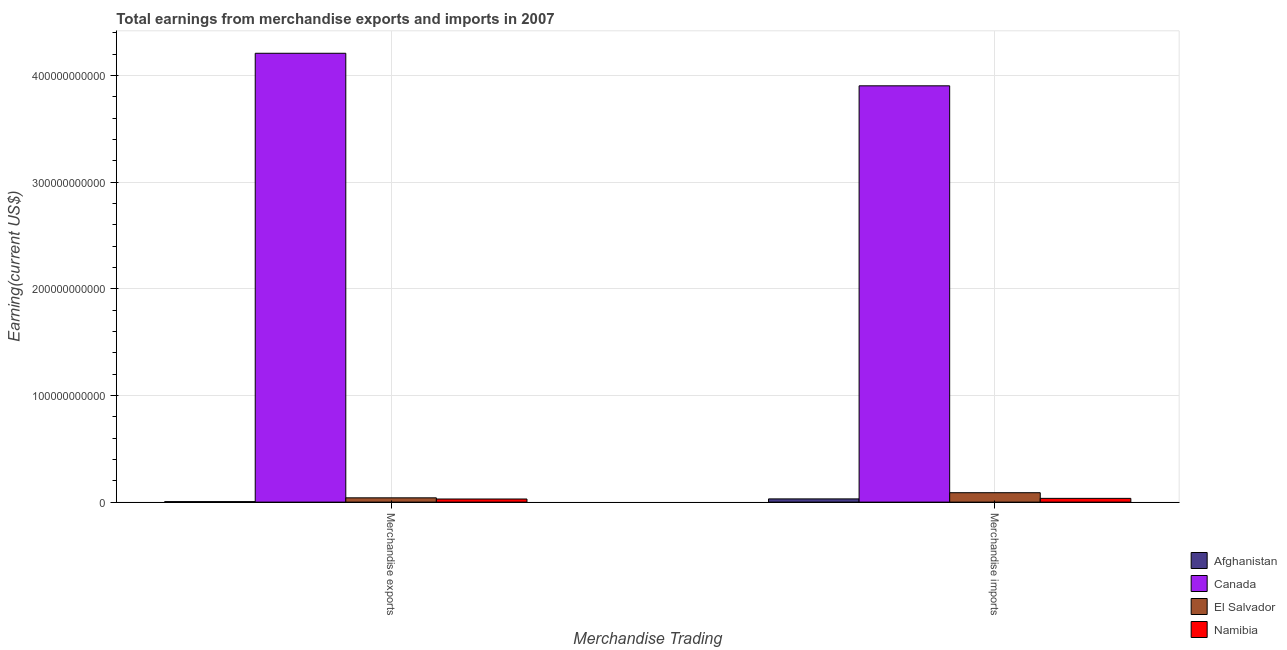How many different coloured bars are there?
Your answer should be very brief. 4. How many groups of bars are there?
Provide a short and direct response. 2. Are the number of bars per tick equal to the number of legend labels?
Your answer should be very brief. Yes. Are the number of bars on each tick of the X-axis equal?
Ensure brevity in your answer.  Yes. How many bars are there on the 2nd tick from the right?
Give a very brief answer. 4. What is the earnings from merchandise exports in Canada?
Your response must be concise. 4.21e+11. Across all countries, what is the maximum earnings from merchandise imports?
Make the answer very short. 3.90e+11. Across all countries, what is the minimum earnings from merchandise exports?
Make the answer very short. 4.54e+08. In which country was the earnings from merchandise imports maximum?
Make the answer very short. Canada. In which country was the earnings from merchandise exports minimum?
Give a very brief answer. Afghanistan. What is the total earnings from merchandise exports in the graph?
Offer a very short reply. 4.28e+11. What is the difference between the earnings from merchandise exports in Afghanistan and that in Namibia?
Offer a terse response. -2.47e+09. What is the difference between the earnings from merchandise imports in Afghanistan and the earnings from merchandise exports in Canada?
Your answer should be very brief. -4.18e+11. What is the average earnings from merchandise imports per country?
Your answer should be very brief. 1.01e+11. What is the difference between the earnings from merchandise exports and earnings from merchandise imports in Canada?
Offer a very short reply. 3.05e+1. What is the ratio of the earnings from merchandise imports in Afghanistan to that in Namibia?
Offer a very short reply. 0.86. What does the 1st bar from the left in Merchandise imports represents?
Provide a succinct answer. Afghanistan. What does the 1st bar from the right in Merchandise exports represents?
Give a very brief answer. Namibia. What is the difference between two consecutive major ticks on the Y-axis?
Give a very brief answer. 1.00e+11. Where does the legend appear in the graph?
Make the answer very short. Bottom right. How are the legend labels stacked?
Give a very brief answer. Vertical. What is the title of the graph?
Your answer should be very brief. Total earnings from merchandise exports and imports in 2007. What is the label or title of the X-axis?
Your answer should be compact. Merchandise Trading. What is the label or title of the Y-axis?
Provide a succinct answer. Earning(current US$). What is the Earning(current US$) of Afghanistan in Merchandise exports?
Ensure brevity in your answer.  4.54e+08. What is the Earning(current US$) of Canada in Merchandise exports?
Offer a terse response. 4.21e+11. What is the Earning(current US$) of El Salvador in Merchandise exports?
Give a very brief answer. 4.01e+09. What is the Earning(current US$) of Namibia in Merchandise exports?
Your answer should be compact. 2.92e+09. What is the Earning(current US$) of Afghanistan in Merchandise imports?
Your answer should be very brief. 3.02e+09. What is the Earning(current US$) in Canada in Merchandise imports?
Make the answer very short. 3.90e+11. What is the Earning(current US$) in El Salvador in Merchandise imports?
Give a very brief answer. 8.82e+09. What is the Earning(current US$) in Namibia in Merchandise imports?
Provide a succinct answer. 3.52e+09. Across all Merchandise Trading, what is the maximum Earning(current US$) in Afghanistan?
Offer a very short reply. 3.02e+09. Across all Merchandise Trading, what is the maximum Earning(current US$) in Canada?
Give a very brief answer. 4.21e+11. Across all Merchandise Trading, what is the maximum Earning(current US$) of El Salvador?
Your response must be concise. 8.82e+09. Across all Merchandise Trading, what is the maximum Earning(current US$) in Namibia?
Make the answer very short. 3.52e+09. Across all Merchandise Trading, what is the minimum Earning(current US$) of Afghanistan?
Make the answer very short. 4.54e+08. Across all Merchandise Trading, what is the minimum Earning(current US$) of Canada?
Your answer should be very brief. 3.90e+11. Across all Merchandise Trading, what is the minimum Earning(current US$) of El Salvador?
Ensure brevity in your answer.  4.01e+09. Across all Merchandise Trading, what is the minimum Earning(current US$) of Namibia?
Provide a short and direct response. 2.92e+09. What is the total Earning(current US$) of Afghanistan in the graph?
Make the answer very short. 3.48e+09. What is the total Earning(current US$) in Canada in the graph?
Make the answer very short. 8.11e+11. What is the total Earning(current US$) of El Salvador in the graph?
Your answer should be very brief. 1.28e+1. What is the total Earning(current US$) of Namibia in the graph?
Make the answer very short. 6.44e+09. What is the difference between the Earning(current US$) in Afghanistan in Merchandise exports and that in Merchandise imports?
Provide a succinct answer. -2.57e+09. What is the difference between the Earning(current US$) of Canada in Merchandise exports and that in Merchandise imports?
Provide a succinct answer. 3.05e+1. What is the difference between the Earning(current US$) in El Salvador in Merchandise exports and that in Merchandise imports?
Offer a very short reply. -4.81e+09. What is the difference between the Earning(current US$) of Namibia in Merchandise exports and that in Merchandise imports?
Your answer should be very brief. -5.98e+08. What is the difference between the Earning(current US$) in Afghanistan in Merchandise exports and the Earning(current US$) in Canada in Merchandise imports?
Offer a terse response. -3.90e+11. What is the difference between the Earning(current US$) of Afghanistan in Merchandise exports and the Earning(current US$) of El Salvador in Merchandise imports?
Offer a very short reply. -8.37e+09. What is the difference between the Earning(current US$) in Afghanistan in Merchandise exports and the Earning(current US$) in Namibia in Merchandise imports?
Provide a short and direct response. -3.07e+09. What is the difference between the Earning(current US$) in Canada in Merchandise exports and the Earning(current US$) in El Salvador in Merchandise imports?
Provide a succinct answer. 4.12e+11. What is the difference between the Earning(current US$) of Canada in Merchandise exports and the Earning(current US$) of Namibia in Merchandise imports?
Give a very brief answer. 4.17e+11. What is the difference between the Earning(current US$) of El Salvador in Merchandise exports and the Earning(current US$) of Namibia in Merchandise imports?
Provide a succinct answer. 4.94e+08. What is the average Earning(current US$) in Afghanistan per Merchandise Trading?
Provide a succinct answer. 1.74e+09. What is the average Earning(current US$) in Canada per Merchandise Trading?
Make the answer very short. 4.05e+11. What is the average Earning(current US$) in El Salvador per Merchandise Trading?
Provide a short and direct response. 6.42e+09. What is the average Earning(current US$) in Namibia per Merchandise Trading?
Provide a succinct answer. 3.22e+09. What is the difference between the Earning(current US$) of Afghanistan and Earning(current US$) of Canada in Merchandise exports?
Keep it short and to the point. -4.20e+11. What is the difference between the Earning(current US$) of Afghanistan and Earning(current US$) of El Salvador in Merchandise exports?
Provide a short and direct response. -3.56e+09. What is the difference between the Earning(current US$) of Afghanistan and Earning(current US$) of Namibia in Merchandise exports?
Offer a very short reply. -2.47e+09. What is the difference between the Earning(current US$) of Canada and Earning(current US$) of El Salvador in Merchandise exports?
Ensure brevity in your answer.  4.17e+11. What is the difference between the Earning(current US$) in Canada and Earning(current US$) in Namibia in Merchandise exports?
Provide a succinct answer. 4.18e+11. What is the difference between the Earning(current US$) of El Salvador and Earning(current US$) of Namibia in Merchandise exports?
Offer a very short reply. 1.09e+09. What is the difference between the Earning(current US$) of Afghanistan and Earning(current US$) of Canada in Merchandise imports?
Provide a succinct answer. -3.87e+11. What is the difference between the Earning(current US$) in Afghanistan and Earning(current US$) in El Salvador in Merchandise imports?
Offer a very short reply. -5.80e+09. What is the difference between the Earning(current US$) of Afghanistan and Earning(current US$) of Namibia in Merchandise imports?
Provide a succinct answer. -4.98e+08. What is the difference between the Earning(current US$) in Canada and Earning(current US$) in El Salvador in Merchandise imports?
Offer a very short reply. 3.81e+11. What is the difference between the Earning(current US$) in Canada and Earning(current US$) in Namibia in Merchandise imports?
Keep it short and to the point. 3.87e+11. What is the difference between the Earning(current US$) of El Salvador and Earning(current US$) of Namibia in Merchandise imports?
Keep it short and to the point. 5.30e+09. What is the ratio of the Earning(current US$) in Afghanistan in Merchandise exports to that in Merchandise imports?
Keep it short and to the point. 0.15. What is the ratio of the Earning(current US$) of Canada in Merchandise exports to that in Merchandise imports?
Your answer should be compact. 1.08. What is the ratio of the Earning(current US$) of El Salvador in Merchandise exports to that in Merchandise imports?
Keep it short and to the point. 0.46. What is the ratio of the Earning(current US$) in Namibia in Merchandise exports to that in Merchandise imports?
Keep it short and to the point. 0.83. What is the difference between the highest and the second highest Earning(current US$) in Afghanistan?
Make the answer very short. 2.57e+09. What is the difference between the highest and the second highest Earning(current US$) in Canada?
Provide a short and direct response. 3.05e+1. What is the difference between the highest and the second highest Earning(current US$) in El Salvador?
Offer a terse response. 4.81e+09. What is the difference between the highest and the second highest Earning(current US$) of Namibia?
Your answer should be compact. 5.98e+08. What is the difference between the highest and the lowest Earning(current US$) of Afghanistan?
Keep it short and to the point. 2.57e+09. What is the difference between the highest and the lowest Earning(current US$) in Canada?
Give a very brief answer. 3.05e+1. What is the difference between the highest and the lowest Earning(current US$) of El Salvador?
Provide a short and direct response. 4.81e+09. What is the difference between the highest and the lowest Earning(current US$) in Namibia?
Ensure brevity in your answer.  5.98e+08. 